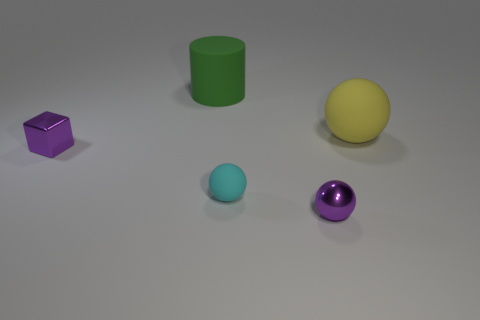What is the tiny purple cube made of?
Your response must be concise. Metal. There is a purple object in front of the rubber ball that is on the left side of the big sphere that is behind the small purple block; what is its material?
Your answer should be very brief. Metal. Do the tiny object to the left of the tiny cyan rubber sphere and the tiny metal thing right of the large green object have the same color?
Make the answer very short. Yes. What is the material of the purple thing that is behind the purple object to the right of the large rubber cylinder?
Make the answer very short. Metal. How many metal things are tiny blue cylinders or big yellow things?
Keep it short and to the point. 0. The other rubber object that is the same shape as the large yellow object is what color?
Your response must be concise. Cyan. How many small metal objects have the same color as the metal ball?
Make the answer very short. 1. Are there any shiny things that are to the left of the purple object to the right of the matte cylinder?
Your response must be concise. Yes. What number of things are both on the left side of the big rubber sphere and in front of the large green cylinder?
Ensure brevity in your answer.  3. What number of cyan things have the same material as the green cylinder?
Your answer should be compact. 1. 